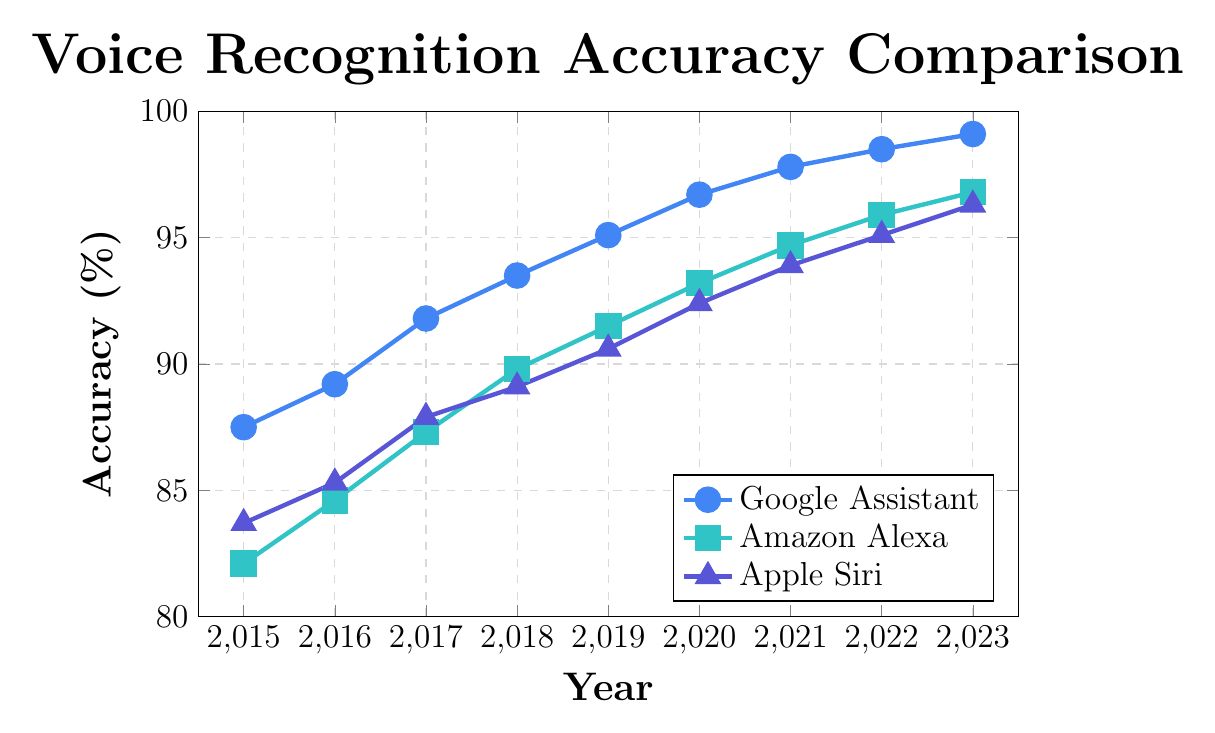What's the trend of Google Assistant's voice recognition accuracy from 2015 to 2023? By looking at the line chart for Google Assistant, which is represented in blue, we observe that its voice recognition accuracy increases continuously from 87.5% in 2015 to 99.1% in 2023. This indicates a steady improvement over the years.
Answer: A continuous increase How does Amazon Alexa's accuracy in 2023 compare to its accuracy in 2015? In the chart, Amazon Alexa's accuracy in 2015 is 82.1%, and it increases to 96.8% in 2023. Subtracting the values, the increase in accuracy is 96.8% - 82.1% = 14.7%.
Answer: It increased by 14.7% Which virtual assistant had the highest voice recognition accuracy in 2020? In 2020, the line chart shows that Google Assistant has the highest accuracy at 96.7%, followed by Amazon Alexa at 93.2%, and Apple Siri at 92.4%.
Answer: Google Assistant Compare the accuracy of Apple Siri and Google Assistant in 2018. In 2018, Google Assistant's accuracy is 93.5%, and Apple Siri’s accuracy is 89.1%, as shown in the chart. Google Assistant’s accuracy is clearly higher.
Answer: Google Assistant is higher Between which years did Google Assistant experience the most significant increase in accuracy? By observing the increasing slope of Google Assistant’s line, the most significant increase occurs between 2017 and 2018, where the accuracy jumps from 91.8% to 93.5%, a difference of 1.7%.
Answer: 2017 to 2018 What was the average voice recognition accuracy of Amazon Alexa from 2015 to 2023? To find the average, sum all accuracy values for Amazon Alexa from 2015 to 2023 and divide by the number of years: (82.1 + 84.6 + 87.3 + 89.8 + 91.5 + 93.2 + 94.7 + 95.9 + 96.8) / 9 = 90.62%.
Answer: 90.62% What's the difference in the accuracy increase for Apple Siri between the periods 2015-2019 and 2019-2023? In 2015, Apple Siri's accuracy is 83.7%, and it is 90.6% in 2019, hence an increase of 90.6% - 83.7% = 6.9%. From 2019 to 2023, accuracy increases from 90.6% to 96.3%, an increase of 96.3% - 90.6% = 5.7%. Thus, the difference in increases is 6.9% - 5.7%.
Answer: 1.2% Which assistant had the smallest improvement over the entire period, and what is the value of improvement? Apple Siri had the smallest improvement from 83.7% in 2015 to 96.3% in 2023. The improvement is 96.3% - 83.7% = 12.6%.
Answer: Apple Siri with 12.6% What year did all three assistants have an accuracy above 90%? By analyzing the data chart, all three assistants first exceeded 90% accuracy in 2019: Google Assistant (95.1%), Amazon Alexa (91.5%), and Apple Siri (90.6%).
Answer: 2019 